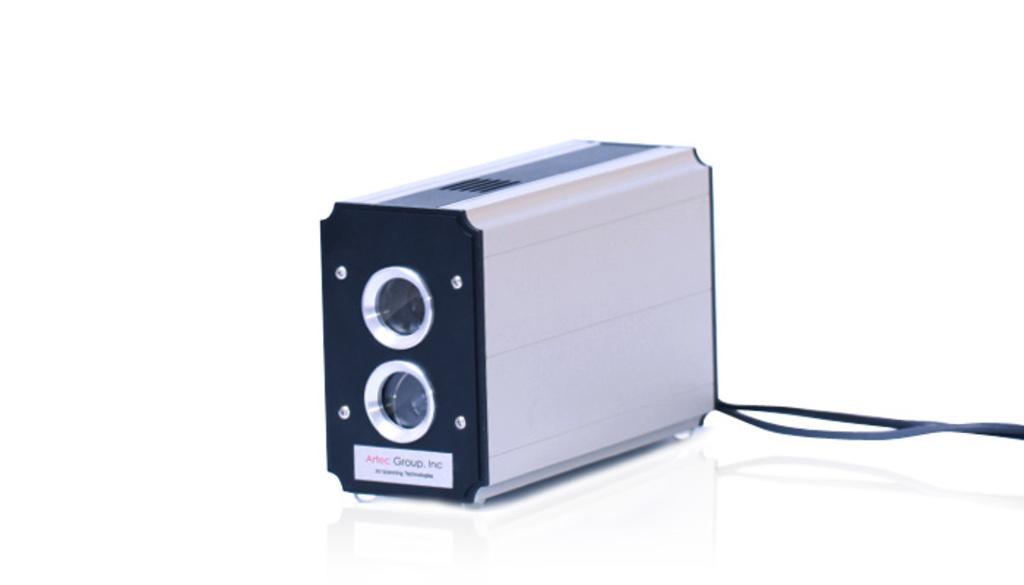Can you describe this image briefly? In this picture we can see a device with a black strap on a white surface and we can see a sticky note on it. 